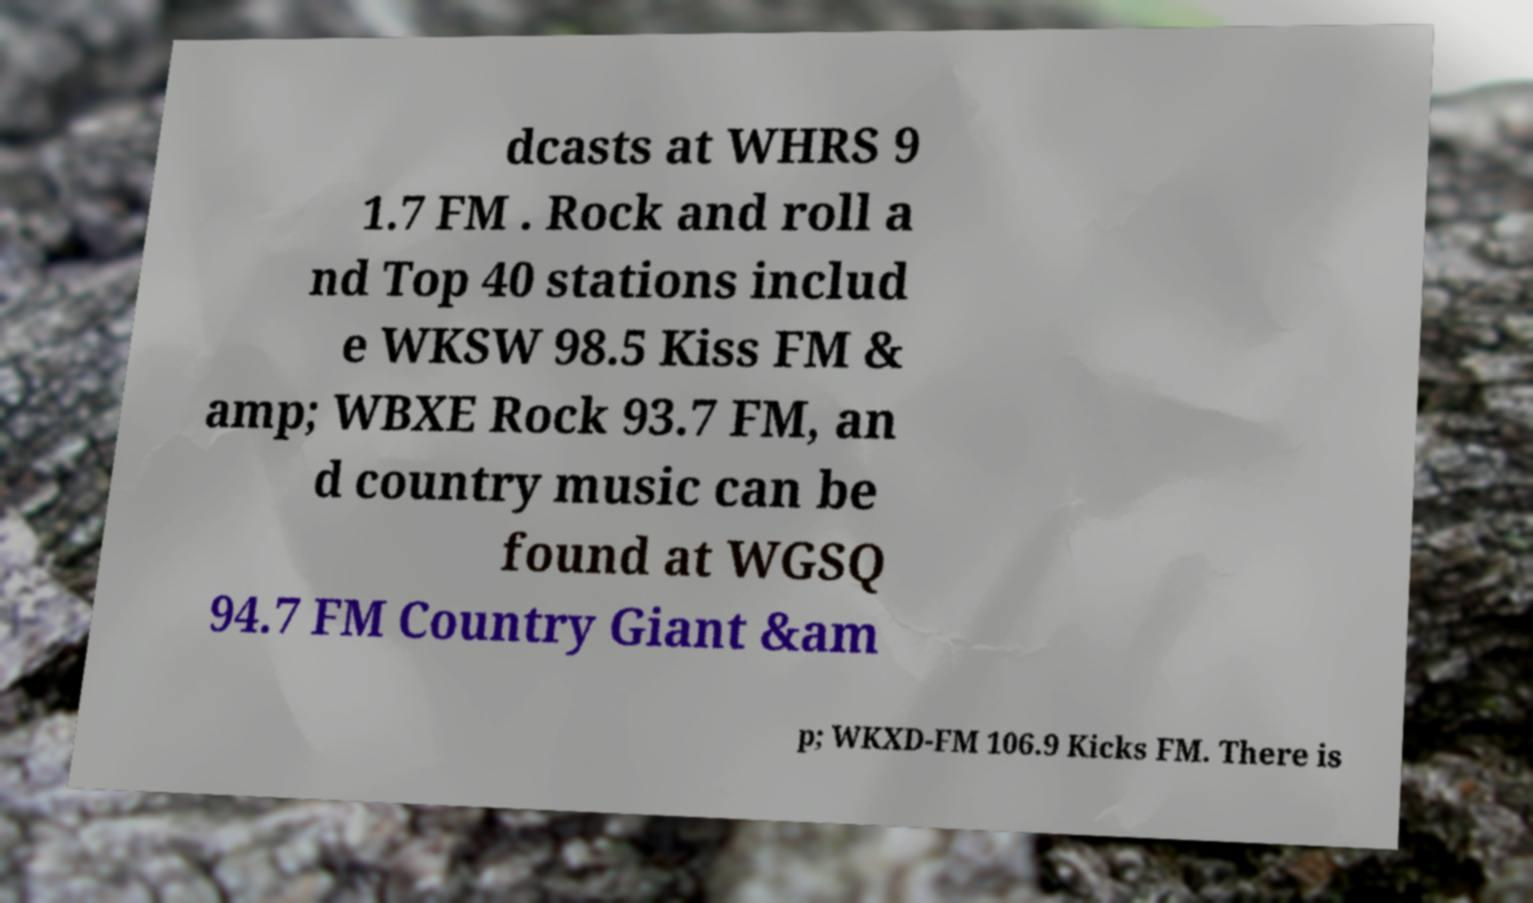For documentation purposes, I need the text within this image transcribed. Could you provide that? dcasts at WHRS 9 1.7 FM . Rock and roll a nd Top 40 stations includ e WKSW 98.5 Kiss FM & amp; WBXE Rock 93.7 FM, an d country music can be found at WGSQ 94.7 FM Country Giant &am p; WKXD-FM 106.9 Kicks FM. There is 